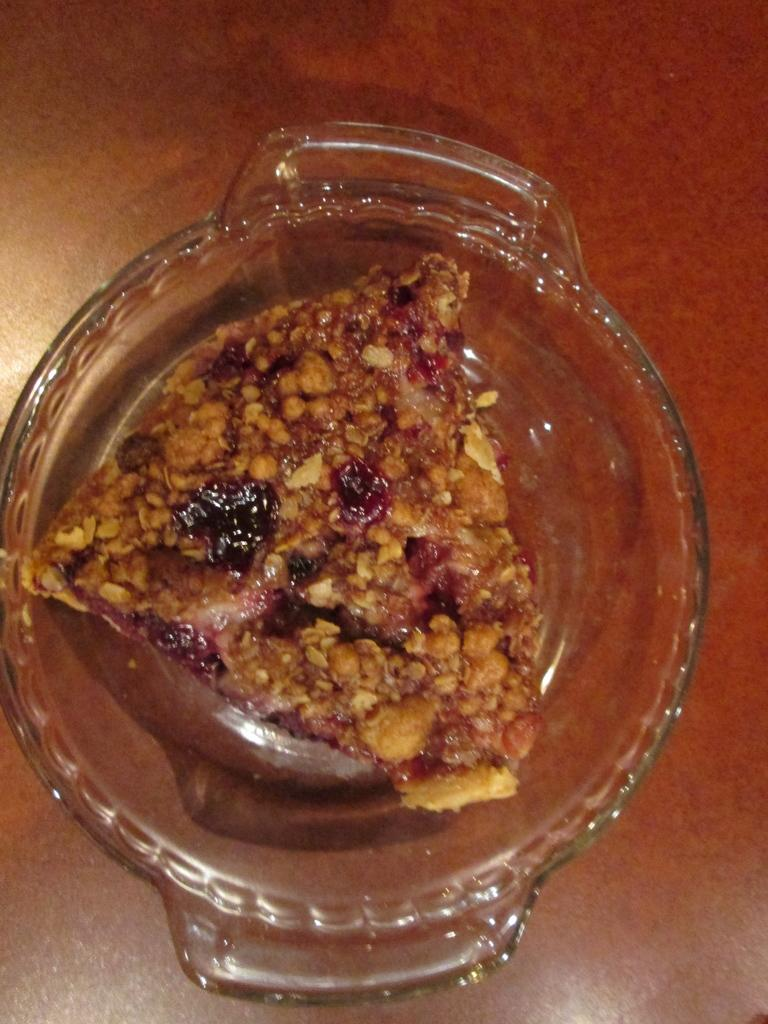What type of container is holding the food in the image? There is food in a glass bowl in the image. Can you describe the setting in which the food is located? There appears to be a table in the background of the image. What is the name of the daughter who is feeding the monkey in the image? There is no daughter or monkey present in the image. 